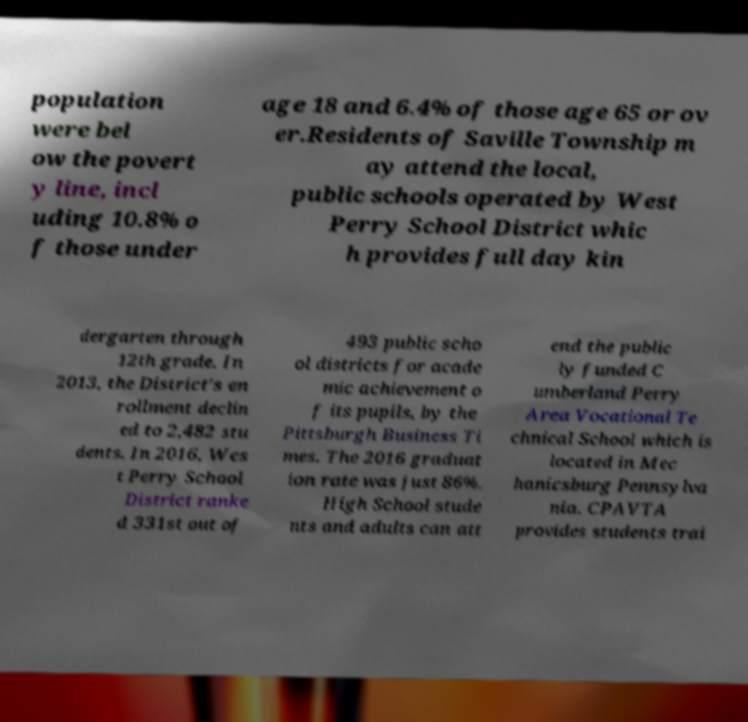Please identify and transcribe the text found in this image. population were bel ow the povert y line, incl uding 10.8% o f those under age 18 and 6.4% of those age 65 or ov er.Residents of Saville Township m ay attend the local, public schools operated by West Perry School District whic h provides full day kin dergarten through 12th grade. In 2013, the District's en rollment declin ed to 2,482 stu dents. In 2016, Wes t Perry School District ranke d 331st out of 493 public scho ol districts for acade mic achievement o f its pupils, by the Pittsburgh Business Ti mes. The 2016 graduat ion rate was just 86%. High School stude nts and adults can att end the public ly funded C umberland Perry Area Vocational Te chnical School which is located in Mec hanicsburg Pennsylva nia. CPAVTA provides students trai 